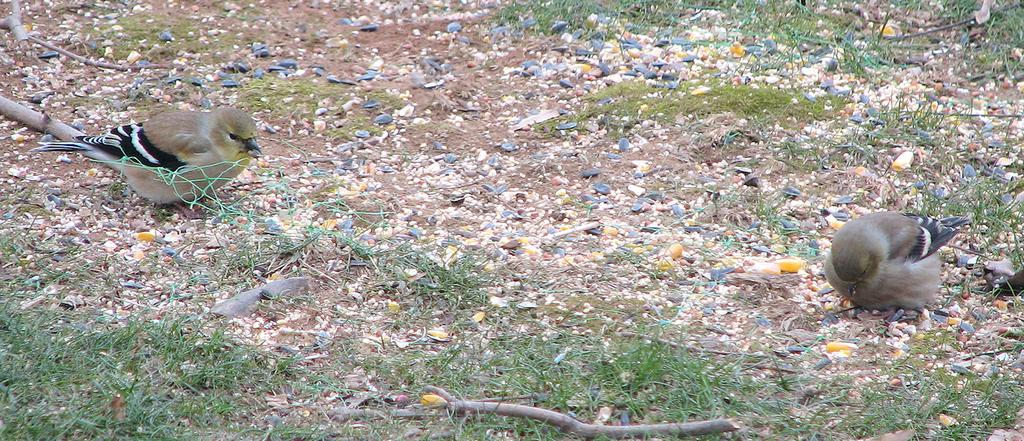What animals can be seen in the image? There are two birds on the ground in the image. What type of vegetation is visible in the image? There is grass visible in the image. What other objects can be seen on the ground? There are stones present in the image. What nation is represented by the birds in the image? The image does not represent any specific nation, as it simply shows two birds on the ground. What type of friction might the birds experience while walking on the stones? The image does not depict the birds walking or experiencing friction, as they are stationary on the ground. 